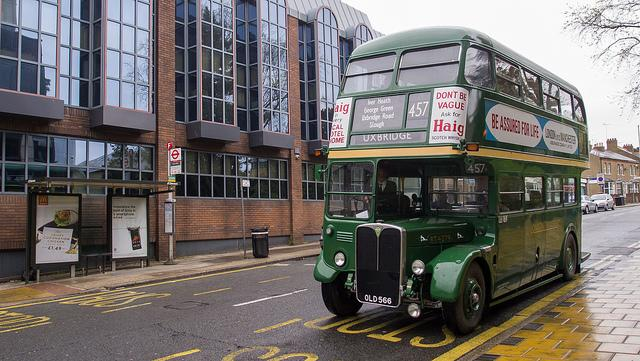What type of infrastructure does this city avoid having?

Choices:
A) low overpasses
B) sidewalks
C) aqueducts
D) bridges low overpasses 